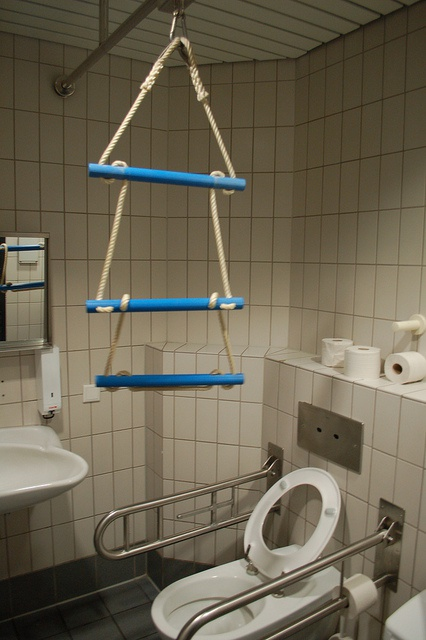Describe the objects in this image and their specific colors. I can see toilet in black, darkgray, and gray tones and sink in black, darkgray, and gray tones in this image. 